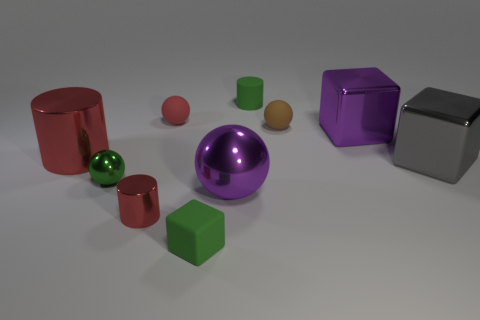There is a metallic thing that is the same color as the tiny metal cylinder; what shape is it?
Your response must be concise. Cylinder. There is a matte cylinder that is the same color as the tiny metallic ball; what is its size?
Keep it short and to the point. Small. What number of matte balls have the same color as the small metallic cylinder?
Give a very brief answer. 1. What material is the tiny sphere that is the same color as the matte cylinder?
Offer a very short reply. Metal. Do the large metal cylinder and the small metal cylinder have the same color?
Provide a short and direct response. Yes. The green rubber block is what size?
Make the answer very short. Small. What is the material of the gray thing that is the same size as the purple ball?
Offer a very short reply. Metal. There is a green cube; what number of shiny spheres are on the left side of it?
Make the answer very short. 1. Does the big thing to the left of the red matte thing have the same material as the tiny brown object that is to the right of the purple metallic ball?
Keep it short and to the point. No. What is the shape of the small green rubber object that is behind the tiny cylinder in front of the matte ball that is on the left side of the green cylinder?
Give a very brief answer. Cylinder. 